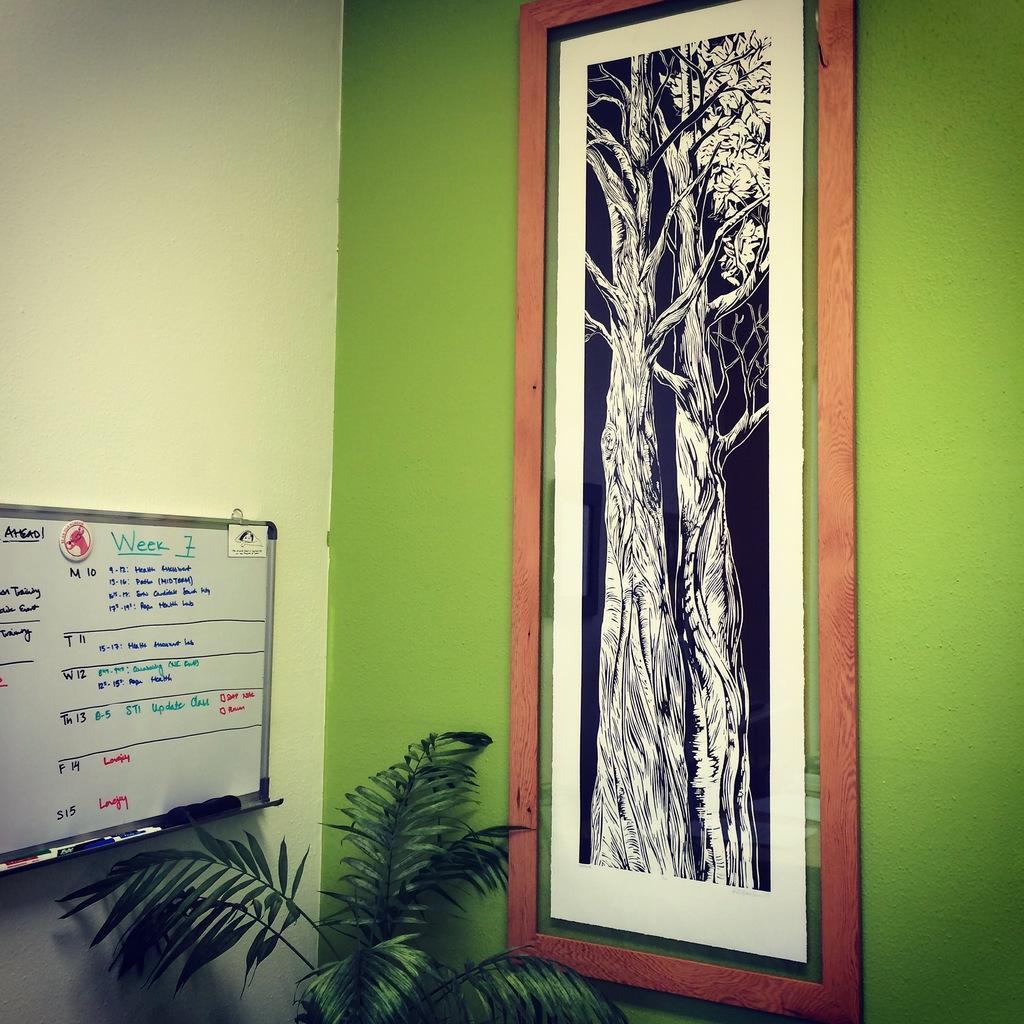How would you summarize this image in a sentence or two? In the center of the image there is a wall and one plant. On the wall, we can see one frame and a board. On the board, we can see some text and some objects. 